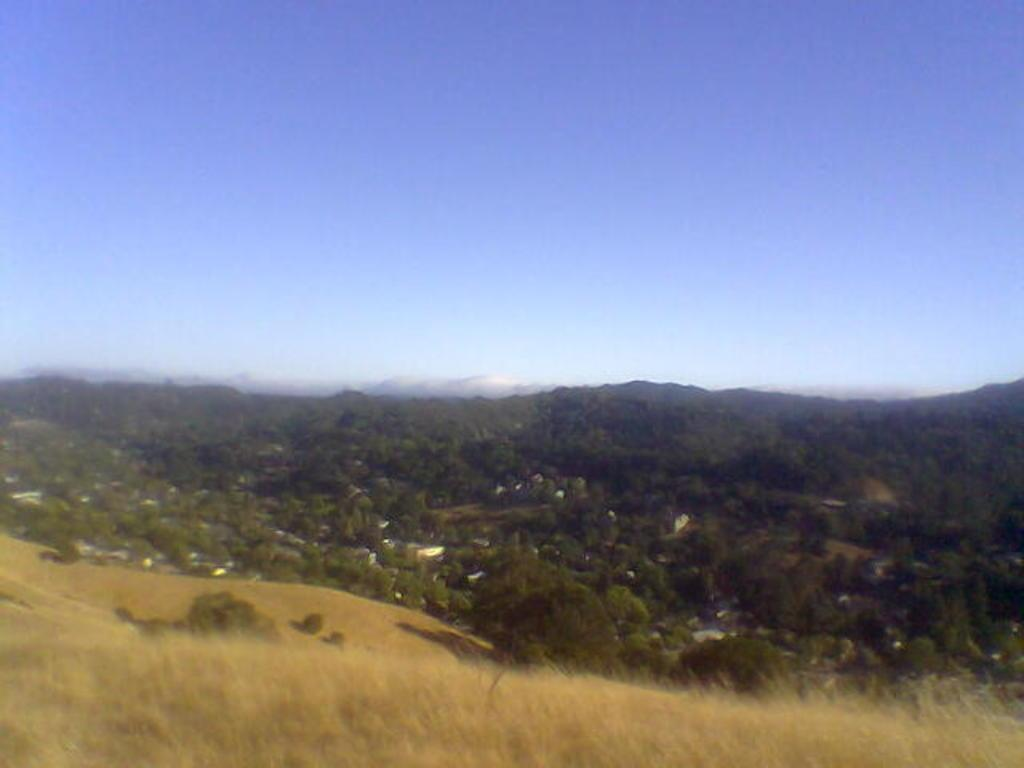What type of surface is visible in the image? There is grass on the surface in the image. What can be seen in the background of the image? There are trees, buildings, mountains, and the sky visible in the background of the image. What type of bells can be heard ringing in the image? There are no bells present in the image, and therefore no sound can be heard. 